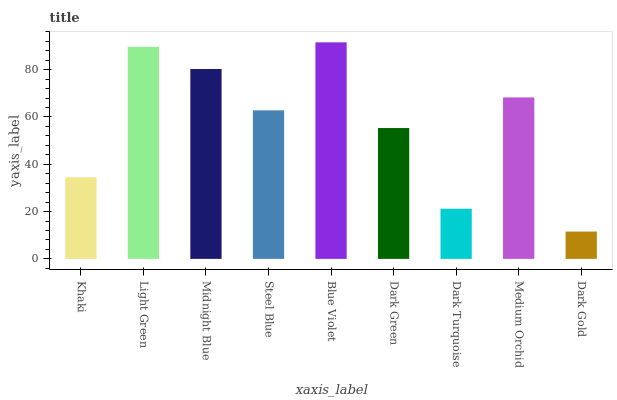Is Dark Gold the minimum?
Answer yes or no. Yes. Is Blue Violet the maximum?
Answer yes or no. Yes. Is Light Green the minimum?
Answer yes or no. No. Is Light Green the maximum?
Answer yes or no. No. Is Light Green greater than Khaki?
Answer yes or no. Yes. Is Khaki less than Light Green?
Answer yes or no. Yes. Is Khaki greater than Light Green?
Answer yes or no. No. Is Light Green less than Khaki?
Answer yes or no. No. Is Steel Blue the high median?
Answer yes or no. Yes. Is Steel Blue the low median?
Answer yes or no. Yes. Is Light Green the high median?
Answer yes or no. No. Is Midnight Blue the low median?
Answer yes or no. No. 